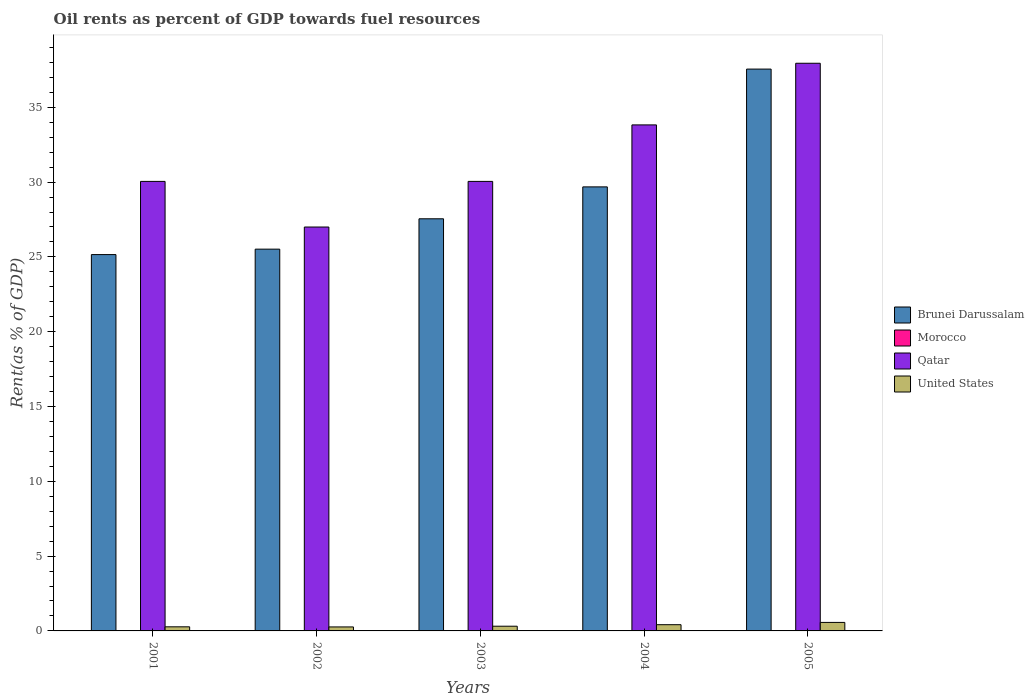How many different coloured bars are there?
Make the answer very short. 4. How many groups of bars are there?
Offer a terse response. 5. Are the number of bars per tick equal to the number of legend labels?
Your answer should be very brief. Yes. Are the number of bars on each tick of the X-axis equal?
Your response must be concise. Yes. In how many cases, is the number of bars for a given year not equal to the number of legend labels?
Offer a very short reply. 0. What is the oil rent in Brunei Darussalam in 2005?
Your response must be concise. 37.55. Across all years, what is the maximum oil rent in Qatar?
Ensure brevity in your answer.  37.94. Across all years, what is the minimum oil rent in Morocco?
Your response must be concise. 0. In which year was the oil rent in United States minimum?
Make the answer very short. 2002. What is the total oil rent in Brunei Darussalam in the graph?
Make the answer very short. 145.45. What is the difference between the oil rent in Qatar in 2003 and that in 2004?
Give a very brief answer. -3.78. What is the difference between the oil rent in Brunei Darussalam in 2001 and the oil rent in United States in 2004?
Offer a very short reply. 24.74. What is the average oil rent in Morocco per year?
Provide a succinct answer. 0. In the year 2005, what is the difference between the oil rent in United States and oil rent in Brunei Darussalam?
Ensure brevity in your answer.  -36.98. What is the ratio of the oil rent in Qatar in 2002 to that in 2003?
Keep it short and to the point. 0.9. Is the oil rent in Morocco in 2001 less than that in 2004?
Provide a succinct answer. Yes. What is the difference between the highest and the second highest oil rent in Brunei Darussalam?
Make the answer very short. 7.87. What is the difference between the highest and the lowest oil rent in Qatar?
Your answer should be very brief. 10.95. In how many years, is the oil rent in United States greater than the average oil rent in United States taken over all years?
Offer a terse response. 2. What does the 4th bar from the left in 2005 represents?
Your answer should be compact. United States. What does the 3rd bar from the right in 2002 represents?
Make the answer very short. Morocco. Is it the case that in every year, the sum of the oil rent in Morocco and oil rent in Qatar is greater than the oil rent in Brunei Darussalam?
Give a very brief answer. Yes. How many bars are there?
Your answer should be compact. 20. How many years are there in the graph?
Make the answer very short. 5. What is the difference between two consecutive major ticks on the Y-axis?
Offer a terse response. 5. Are the values on the major ticks of Y-axis written in scientific E-notation?
Ensure brevity in your answer.  No. Does the graph contain any zero values?
Provide a short and direct response. No. Does the graph contain grids?
Provide a succinct answer. No. How many legend labels are there?
Provide a succinct answer. 4. What is the title of the graph?
Keep it short and to the point. Oil rents as percent of GDP towards fuel resources. What is the label or title of the X-axis?
Your answer should be compact. Years. What is the label or title of the Y-axis?
Provide a short and direct response. Rent(as % of GDP). What is the Rent(as % of GDP) in Brunei Darussalam in 2001?
Make the answer very short. 25.15. What is the Rent(as % of GDP) of Morocco in 2001?
Your answer should be compact. 0. What is the Rent(as % of GDP) of Qatar in 2001?
Ensure brevity in your answer.  30.05. What is the Rent(as % of GDP) in United States in 2001?
Your answer should be compact. 0.27. What is the Rent(as % of GDP) in Brunei Darussalam in 2002?
Make the answer very short. 25.52. What is the Rent(as % of GDP) in Morocco in 2002?
Your answer should be compact. 0. What is the Rent(as % of GDP) in Qatar in 2002?
Offer a very short reply. 27. What is the Rent(as % of GDP) of United States in 2002?
Provide a short and direct response. 0.27. What is the Rent(as % of GDP) in Brunei Darussalam in 2003?
Offer a very short reply. 27.55. What is the Rent(as % of GDP) in Morocco in 2003?
Give a very brief answer. 0. What is the Rent(as % of GDP) of Qatar in 2003?
Offer a terse response. 30.05. What is the Rent(as % of GDP) of United States in 2003?
Your response must be concise. 0.31. What is the Rent(as % of GDP) in Brunei Darussalam in 2004?
Provide a short and direct response. 29.68. What is the Rent(as % of GDP) of Morocco in 2004?
Your response must be concise. 0. What is the Rent(as % of GDP) of Qatar in 2004?
Give a very brief answer. 33.82. What is the Rent(as % of GDP) of United States in 2004?
Offer a very short reply. 0.42. What is the Rent(as % of GDP) of Brunei Darussalam in 2005?
Provide a short and direct response. 37.55. What is the Rent(as % of GDP) of Morocco in 2005?
Make the answer very short. 0. What is the Rent(as % of GDP) of Qatar in 2005?
Offer a terse response. 37.94. What is the Rent(as % of GDP) of United States in 2005?
Provide a short and direct response. 0.57. Across all years, what is the maximum Rent(as % of GDP) of Brunei Darussalam?
Provide a succinct answer. 37.55. Across all years, what is the maximum Rent(as % of GDP) of Morocco?
Provide a succinct answer. 0. Across all years, what is the maximum Rent(as % of GDP) in Qatar?
Give a very brief answer. 37.94. Across all years, what is the maximum Rent(as % of GDP) in United States?
Keep it short and to the point. 0.57. Across all years, what is the minimum Rent(as % of GDP) of Brunei Darussalam?
Offer a very short reply. 25.15. Across all years, what is the minimum Rent(as % of GDP) of Morocco?
Your answer should be very brief. 0. Across all years, what is the minimum Rent(as % of GDP) of Qatar?
Your answer should be compact. 27. Across all years, what is the minimum Rent(as % of GDP) of United States?
Offer a very short reply. 0.27. What is the total Rent(as % of GDP) in Brunei Darussalam in the graph?
Your response must be concise. 145.45. What is the total Rent(as % of GDP) of Morocco in the graph?
Offer a terse response. 0.02. What is the total Rent(as % of GDP) of Qatar in the graph?
Make the answer very short. 158.85. What is the total Rent(as % of GDP) in United States in the graph?
Offer a terse response. 1.84. What is the difference between the Rent(as % of GDP) of Brunei Darussalam in 2001 and that in 2002?
Provide a succinct answer. -0.36. What is the difference between the Rent(as % of GDP) in Morocco in 2001 and that in 2002?
Your answer should be very brief. -0. What is the difference between the Rent(as % of GDP) of Qatar in 2001 and that in 2002?
Keep it short and to the point. 3.05. What is the difference between the Rent(as % of GDP) of United States in 2001 and that in 2002?
Offer a terse response. 0.01. What is the difference between the Rent(as % of GDP) of Brunei Darussalam in 2001 and that in 2003?
Keep it short and to the point. -2.39. What is the difference between the Rent(as % of GDP) of United States in 2001 and that in 2003?
Offer a very short reply. -0.04. What is the difference between the Rent(as % of GDP) of Brunei Darussalam in 2001 and that in 2004?
Your answer should be compact. -4.53. What is the difference between the Rent(as % of GDP) of Morocco in 2001 and that in 2004?
Make the answer very short. -0. What is the difference between the Rent(as % of GDP) of Qatar in 2001 and that in 2004?
Your answer should be compact. -3.78. What is the difference between the Rent(as % of GDP) of United States in 2001 and that in 2004?
Your response must be concise. -0.14. What is the difference between the Rent(as % of GDP) of Brunei Darussalam in 2001 and that in 2005?
Give a very brief answer. -12.4. What is the difference between the Rent(as % of GDP) of Morocco in 2001 and that in 2005?
Offer a very short reply. -0. What is the difference between the Rent(as % of GDP) of Qatar in 2001 and that in 2005?
Offer a very short reply. -7.9. What is the difference between the Rent(as % of GDP) of United States in 2001 and that in 2005?
Give a very brief answer. -0.29. What is the difference between the Rent(as % of GDP) of Brunei Darussalam in 2002 and that in 2003?
Your answer should be very brief. -2.03. What is the difference between the Rent(as % of GDP) in Morocco in 2002 and that in 2003?
Provide a short and direct response. 0. What is the difference between the Rent(as % of GDP) in Qatar in 2002 and that in 2003?
Ensure brevity in your answer.  -3.05. What is the difference between the Rent(as % of GDP) of United States in 2002 and that in 2003?
Provide a short and direct response. -0.05. What is the difference between the Rent(as % of GDP) of Brunei Darussalam in 2002 and that in 2004?
Give a very brief answer. -4.16. What is the difference between the Rent(as % of GDP) of Qatar in 2002 and that in 2004?
Your response must be concise. -6.83. What is the difference between the Rent(as % of GDP) of United States in 2002 and that in 2004?
Your answer should be compact. -0.15. What is the difference between the Rent(as % of GDP) in Brunei Darussalam in 2002 and that in 2005?
Make the answer very short. -12.04. What is the difference between the Rent(as % of GDP) in Morocco in 2002 and that in 2005?
Provide a succinct answer. 0. What is the difference between the Rent(as % of GDP) of Qatar in 2002 and that in 2005?
Your response must be concise. -10.95. What is the difference between the Rent(as % of GDP) in United States in 2002 and that in 2005?
Offer a terse response. -0.3. What is the difference between the Rent(as % of GDP) in Brunei Darussalam in 2003 and that in 2004?
Your answer should be compact. -2.13. What is the difference between the Rent(as % of GDP) in Morocco in 2003 and that in 2004?
Offer a very short reply. -0. What is the difference between the Rent(as % of GDP) in Qatar in 2003 and that in 2004?
Offer a terse response. -3.78. What is the difference between the Rent(as % of GDP) of United States in 2003 and that in 2004?
Make the answer very short. -0.1. What is the difference between the Rent(as % of GDP) of Brunei Darussalam in 2003 and that in 2005?
Your answer should be compact. -10.01. What is the difference between the Rent(as % of GDP) in Morocco in 2003 and that in 2005?
Provide a short and direct response. -0. What is the difference between the Rent(as % of GDP) in Qatar in 2003 and that in 2005?
Make the answer very short. -7.9. What is the difference between the Rent(as % of GDP) in United States in 2003 and that in 2005?
Keep it short and to the point. -0.25. What is the difference between the Rent(as % of GDP) in Brunei Darussalam in 2004 and that in 2005?
Your answer should be very brief. -7.87. What is the difference between the Rent(as % of GDP) in Morocco in 2004 and that in 2005?
Your answer should be compact. 0. What is the difference between the Rent(as % of GDP) in Qatar in 2004 and that in 2005?
Keep it short and to the point. -4.12. What is the difference between the Rent(as % of GDP) of United States in 2004 and that in 2005?
Your response must be concise. -0.15. What is the difference between the Rent(as % of GDP) of Brunei Darussalam in 2001 and the Rent(as % of GDP) of Morocco in 2002?
Offer a terse response. 25.15. What is the difference between the Rent(as % of GDP) of Brunei Darussalam in 2001 and the Rent(as % of GDP) of Qatar in 2002?
Make the answer very short. -1.84. What is the difference between the Rent(as % of GDP) in Brunei Darussalam in 2001 and the Rent(as % of GDP) in United States in 2002?
Offer a terse response. 24.89. What is the difference between the Rent(as % of GDP) of Morocco in 2001 and the Rent(as % of GDP) of Qatar in 2002?
Your answer should be compact. -26.99. What is the difference between the Rent(as % of GDP) of Morocco in 2001 and the Rent(as % of GDP) of United States in 2002?
Your response must be concise. -0.26. What is the difference between the Rent(as % of GDP) in Qatar in 2001 and the Rent(as % of GDP) in United States in 2002?
Your answer should be very brief. 29.78. What is the difference between the Rent(as % of GDP) in Brunei Darussalam in 2001 and the Rent(as % of GDP) in Morocco in 2003?
Your answer should be very brief. 25.15. What is the difference between the Rent(as % of GDP) in Brunei Darussalam in 2001 and the Rent(as % of GDP) in Qatar in 2003?
Your answer should be very brief. -4.89. What is the difference between the Rent(as % of GDP) of Brunei Darussalam in 2001 and the Rent(as % of GDP) of United States in 2003?
Offer a very short reply. 24.84. What is the difference between the Rent(as % of GDP) of Morocco in 2001 and the Rent(as % of GDP) of Qatar in 2003?
Provide a succinct answer. -30.04. What is the difference between the Rent(as % of GDP) in Morocco in 2001 and the Rent(as % of GDP) in United States in 2003?
Ensure brevity in your answer.  -0.31. What is the difference between the Rent(as % of GDP) in Qatar in 2001 and the Rent(as % of GDP) in United States in 2003?
Offer a very short reply. 29.73. What is the difference between the Rent(as % of GDP) in Brunei Darussalam in 2001 and the Rent(as % of GDP) in Morocco in 2004?
Keep it short and to the point. 25.15. What is the difference between the Rent(as % of GDP) in Brunei Darussalam in 2001 and the Rent(as % of GDP) in Qatar in 2004?
Provide a succinct answer. -8.67. What is the difference between the Rent(as % of GDP) of Brunei Darussalam in 2001 and the Rent(as % of GDP) of United States in 2004?
Your answer should be compact. 24.74. What is the difference between the Rent(as % of GDP) of Morocco in 2001 and the Rent(as % of GDP) of Qatar in 2004?
Keep it short and to the point. -33.82. What is the difference between the Rent(as % of GDP) of Morocco in 2001 and the Rent(as % of GDP) of United States in 2004?
Offer a very short reply. -0.41. What is the difference between the Rent(as % of GDP) of Qatar in 2001 and the Rent(as % of GDP) of United States in 2004?
Ensure brevity in your answer.  29.63. What is the difference between the Rent(as % of GDP) of Brunei Darussalam in 2001 and the Rent(as % of GDP) of Morocco in 2005?
Your response must be concise. 25.15. What is the difference between the Rent(as % of GDP) in Brunei Darussalam in 2001 and the Rent(as % of GDP) in Qatar in 2005?
Provide a short and direct response. -12.79. What is the difference between the Rent(as % of GDP) of Brunei Darussalam in 2001 and the Rent(as % of GDP) of United States in 2005?
Make the answer very short. 24.59. What is the difference between the Rent(as % of GDP) in Morocco in 2001 and the Rent(as % of GDP) in Qatar in 2005?
Provide a succinct answer. -37.94. What is the difference between the Rent(as % of GDP) in Morocco in 2001 and the Rent(as % of GDP) in United States in 2005?
Ensure brevity in your answer.  -0.56. What is the difference between the Rent(as % of GDP) in Qatar in 2001 and the Rent(as % of GDP) in United States in 2005?
Your response must be concise. 29.48. What is the difference between the Rent(as % of GDP) of Brunei Darussalam in 2002 and the Rent(as % of GDP) of Morocco in 2003?
Your answer should be very brief. 25.51. What is the difference between the Rent(as % of GDP) in Brunei Darussalam in 2002 and the Rent(as % of GDP) in Qatar in 2003?
Ensure brevity in your answer.  -4.53. What is the difference between the Rent(as % of GDP) of Brunei Darussalam in 2002 and the Rent(as % of GDP) of United States in 2003?
Give a very brief answer. 25.2. What is the difference between the Rent(as % of GDP) of Morocco in 2002 and the Rent(as % of GDP) of Qatar in 2003?
Provide a succinct answer. -30.04. What is the difference between the Rent(as % of GDP) in Morocco in 2002 and the Rent(as % of GDP) in United States in 2003?
Provide a short and direct response. -0.31. What is the difference between the Rent(as % of GDP) in Qatar in 2002 and the Rent(as % of GDP) in United States in 2003?
Provide a succinct answer. 26.68. What is the difference between the Rent(as % of GDP) in Brunei Darussalam in 2002 and the Rent(as % of GDP) in Morocco in 2004?
Your answer should be very brief. 25.51. What is the difference between the Rent(as % of GDP) in Brunei Darussalam in 2002 and the Rent(as % of GDP) in Qatar in 2004?
Ensure brevity in your answer.  -8.3. What is the difference between the Rent(as % of GDP) of Brunei Darussalam in 2002 and the Rent(as % of GDP) of United States in 2004?
Make the answer very short. 25.1. What is the difference between the Rent(as % of GDP) of Morocco in 2002 and the Rent(as % of GDP) of Qatar in 2004?
Your answer should be compact. -33.82. What is the difference between the Rent(as % of GDP) in Morocco in 2002 and the Rent(as % of GDP) in United States in 2004?
Offer a terse response. -0.41. What is the difference between the Rent(as % of GDP) in Qatar in 2002 and the Rent(as % of GDP) in United States in 2004?
Ensure brevity in your answer.  26.58. What is the difference between the Rent(as % of GDP) in Brunei Darussalam in 2002 and the Rent(as % of GDP) in Morocco in 2005?
Offer a terse response. 25.51. What is the difference between the Rent(as % of GDP) of Brunei Darussalam in 2002 and the Rent(as % of GDP) of Qatar in 2005?
Provide a succinct answer. -12.43. What is the difference between the Rent(as % of GDP) in Brunei Darussalam in 2002 and the Rent(as % of GDP) in United States in 2005?
Provide a short and direct response. 24.95. What is the difference between the Rent(as % of GDP) in Morocco in 2002 and the Rent(as % of GDP) in Qatar in 2005?
Your response must be concise. -37.94. What is the difference between the Rent(as % of GDP) of Morocco in 2002 and the Rent(as % of GDP) of United States in 2005?
Keep it short and to the point. -0.56. What is the difference between the Rent(as % of GDP) of Qatar in 2002 and the Rent(as % of GDP) of United States in 2005?
Provide a short and direct response. 26.43. What is the difference between the Rent(as % of GDP) of Brunei Darussalam in 2003 and the Rent(as % of GDP) of Morocco in 2004?
Offer a terse response. 27.54. What is the difference between the Rent(as % of GDP) in Brunei Darussalam in 2003 and the Rent(as % of GDP) in Qatar in 2004?
Ensure brevity in your answer.  -6.28. What is the difference between the Rent(as % of GDP) of Brunei Darussalam in 2003 and the Rent(as % of GDP) of United States in 2004?
Keep it short and to the point. 27.13. What is the difference between the Rent(as % of GDP) in Morocco in 2003 and the Rent(as % of GDP) in Qatar in 2004?
Offer a very short reply. -33.82. What is the difference between the Rent(as % of GDP) in Morocco in 2003 and the Rent(as % of GDP) in United States in 2004?
Ensure brevity in your answer.  -0.41. What is the difference between the Rent(as % of GDP) in Qatar in 2003 and the Rent(as % of GDP) in United States in 2004?
Give a very brief answer. 29.63. What is the difference between the Rent(as % of GDP) in Brunei Darussalam in 2003 and the Rent(as % of GDP) in Morocco in 2005?
Ensure brevity in your answer.  27.54. What is the difference between the Rent(as % of GDP) of Brunei Darussalam in 2003 and the Rent(as % of GDP) of Qatar in 2005?
Your answer should be compact. -10.4. What is the difference between the Rent(as % of GDP) of Brunei Darussalam in 2003 and the Rent(as % of GDP) of United States in 2005?
Your answer should be compact. 26.98. What is the difference between the Rent(as % of GDP) of Morocco in 2003 and the Rent(as % of GDP) of Qatar in 2005?
Keep it short and to the point. -37.94. What is the difference between the Rent(as % of GDP) in Morocco in 2003 and the Rent(as % of GDP) in United States in 2005?
Give a very brief answer. -0.57. What is the difference between the Rent(as % of GDP) of Qatar in 2003 and the Rent(as % of GDP) of United States in 2005?
Give a very brief answer. 29.48. What is the difference between the Rent(as % of GDP) of Brunei Darussalam in 2004 and the Rent(as % of GDP) of Morocco in 2005?
Provide a short and direct response. 29.68. What is the difference between the Rent(as % of GDP) of Brunei Darussalam in 2004 and the Rent(as % of GDP) of Qatar in 2005?
Give a very brief answer. -8.26. What is the difference between the Rent(as % of GDP) of Brunei Darussalam in 2004 and the Rent(as % of GDP) of United States in 2005?
Provide a short and direct response. 29.11. What is the difference between the Rent(as % of GDP) in Morocco in 2004 and the Rent(as % of GDP) in Qatar in 2005?
Your response must be concise. -37.94. What is the difference between the Rent(as % of GDP) in Morocco in 2004 and the Rent(as % of GDP) in United States in 2005?
Keep it short and to the point. -0.56. What is the difference between the Rent(as % of GDP) in Qatar in 2004 and the Rent(as % of GDP) in United States in 2005?
Keep it short and to the point. 33.25. What is the average Rent(as % of GDP) of Brunei Darussalam per year?
Make the answer very short. 29.09. What is the average Rent(as % of GDP) in Morocco per year?
Make the answer very short. 0. What is the average Rent(as % of GDP) of Qatar per year?
Provide a succinct answer. 31.77. What is the average Rent(as % of GDP) in United States per year?
Your response must be concise. 0.37. In the year 2001, what is the difference between the Rent(as % of GDP) of Brunei Darussalam and Rent(as % of GDP) of Morocco?
Offer a very short reply. 25.15. In the year 2001, what is the difference between the Rent(as % of GDP) of Brunei Darussalam and Rent(as % of GDP) of Qatar?
Your response must be concise. -4.89. In the year 2001, what is the difference between the Rent(as % of GDP) of Brunei Darussalam and Rent(as % of GDP) of United States?
Provide a short and direct response. 24.88. In the year 2001, what is the difference between the Rent(as % of GDP) in Morocco and Rent(as % of GDP) in Qatar?
Keep it short and to the point. -30.04. In the year 2001, what is the difference between the Rent(as % of GDP) in Morocco and Rent(as % of GDP) in United States?
Keep it short and to the point. -0.27. In the year 2001, what is the difference between the Rent(as % of GDP) of Qatar and Rent(as % of GDP) of United States?
Offer a very short reply. 29.77. In the year 2002, what is the difference between the Rent(as % of GDP) of Brunei Darussalam and Rent(as % of GDP) of Morocco?
Provide a short and direct response. 25.51. In the year 2002, what is the difference between the Rent(as % of GDP) in Brunei Darussalam and Rent(as % of GDP) in Qatar?
Your answer should be compact. -1.48. In the year 2002, what is the difference between the Rent(as % of GDP) of Brunei Darussalam and Rent(as % of GDP) of United States?
Ensure brevity in your answer.  25.25. In the year 2002, what is the difference between the Rent(as % of GDP) in Morocco and Rent(as % of GDP) in Qatar?
Offer a terse response. -26.99. In the year 2002, what is the difference between the Rent(as % of GDP) of Morocco and Rent(as % of GDP) of United States?
Provide a short and direct response. -0.26. In the year 2002, what is the difference between the Rent(as % of GDP) of Qatar and Rent(as % of GDP) of United States?
Your answer should be compact. 26.73. In the year 2003, what is the difference between the Rent(as % of GDP) of Brunei Darussalam and Rent(as % of GDP) of Morocco?
Provide a short and direct response. 27.54. In the year 2003, what is the difference between the Rent(as % of GDP) of Brunei Darussalam and Rent(as % of GDP) of Qatar?
Give a very brief answer. -2.5. In the year 2003, what is the difference between the Rent(as % of GDP) of Brunei Darussalam and Rent(as % of GDP) of United States?
Offer a very short reply. 27.23. In the year 2003, what is the difference between the Rent(as % of GDP) of Morocco and Rent(as % of GDP) of Qatar?
Your answer should be very brief. -30.04. In the year 2003, what is the difference between the Rent(as % of GDP) of Morocco and Rent(as % of GDP) of United States?
Offer a very short reply. -0.31. In the year 2003, what is the difference between the Rent(as % of GDP) in Qatar and Rent(as % of GDP) in United States?
Your response must be concise. 29.73. In the year 2004, what is the difference between the Rent(as % of GDP) of Brunei Darussalam and Rent(as % of GDP) of Morocco?
Your answer should be very brief. 29.67. In the year 2004, what is the difference between the Rent(as % of GDP) of Brunei Darussalam and Rent(as % of GDP) of Qatar?
Your answer should be very brief. -4.14. In the year 2004, what is the difference between the Rent(as % of GDP) of Brunei Darussalam and Rent(as % of GDP) of United States?
Provide a succinct answer. 29.26. In the year 2004, what is the difference between the Rent(as % of GDP) in Morocco and Rent(as % of GDP) in Qatar?
Give a very brief answer. -33.82. In the year 2004, what is the difference between the Rent(as % of GDP) in Morocco and Rent(as % of GDP) in United States?
Give a very brief answer. -0.41. In the year 2004, what is the difference between the Rent(as % of GDP) of Qatar and Rent(as % of GDP) of United States?
Provide a short and direct response. 33.41. In the year 2005, what is the difference between the Rent(as % of GDP) in Brunei Darussalam and Rent(as % of GDP) in Morocco?
Your answer should be very brief. 37.55. In the year 2005, what is the difference between the Rent(as % of GDP) in Brunei Darussalam and Rent(as % of GDP) in Qatar?
Give a very brief answer. -0.39. In the year 2005, what is the difference between the Rent(as % of GDP) of Brunei Darussalam and Rent(as % of GDP) of United States?
Your answer should be very brief. 36.98. In the year 2005, what is the difference between the Rent(as % of GDP) in Morocco and Rent(as % of GDP) in Qatar?
Your answer should be compact. -37.94. In the year 2005, what is the difference between the Rent(as % of GDP) in Morocco and Rent(as % of GDP) in United States?
Keep it short and to the point. -0.56. In the year 2005, what is the difference between the Rent(as % of GDP) in Qatar and Rent(as % of GDP) in United States?
Offer a very short reply. 37.37. What is the ratio of the Rent(as % of GDP) of Brunei Darussalam in 2001 to that in 2002?
Give a very brief answer. 0.99. What is the ratio of the Rent(as % of GDP) of Morocco in 2001 to that in 2002?
Offer a terse response. 0.81. What is the ratio of the Rent(as % of GDP) in Qatar in 2001 to that in 2002?
Ensure brevity in your answer.  1.11. What is the ratio of the Rent(as % of GDP) in United States in 2001 to that in 2002?
Your response must be concise. 1.03. What is the ratio of the Rent(as % of GDP) of Brunei Darussalam in 2001 to that in 2003?
Give a very brief answer. 0.91. What is the ratio of the Rent(as % of GDP) of Morocco in 2001 to that in 2003?
Offer a very short reply. 1.09. What is the ratio of the Rent(as % of GDP) in Qatar in 2001 to that in 2003?
Offer a terse response. 1. What is the ratio of the Rent(as % of GDP) of United States in 2001 to that in 2003?
Your answer should be compact. 0.87. What is the ratio of the Rent(as % of GDP) of Brunei Darussalam in 2001 to that in 2004?
Offer a terse response. 0.85. What is the ratio of the Rent(as % of GDP) of Morocco in 2001 to that in 2004?
Provide a short and direct response. 0.84. What is the ratio of the Rent(as % of GDP) of Qatar in 2001 to that in 2004?
Give a very brief answer. 0.89. What is the ratio of the Rent(as % of GDP) of United States in 2001 to that in 2004?
Ensure brevity in your answer.  0.66. What is the ratio of the Rent(as % of GDP) of Brunei Darussalam in 2001 to that in 2005?
Provide a short and direct response. 0.67. What is the ratio of the Rent(as % of GDP) of Morocco in 2001 to that in 2005?
Your answer should be compact. 0.94. What is the ratio of the Rent(as % of GDP) in Qatar in 2001 to that in 2005?
Offer a very short reply. 0.79. What is the ratio of the Rent(as % of GDP) in United States in 2001 to that in 2005?
Offer a terse response. 0.48. What is the ratio of the Rent(as % of GDP) in Brunei Darussalam in 2002 to that in 2003?
Offer a terse response. 0.93. What is the ratio of the Rent(as % of GDP) of Morocco in 2002 to that in 2003?
Provide a short and direct response. 1.35. What is the ratio of the Rent(as % of GDP) of Qatar in 2002 to that in 2003?
Make the answer very short. 0.9. What is the ratio of the Rent(as % of GDP) of United States in 2002 to that in 2003?
Your answer should be compact. 0.85. What is the ratio of the Rent(as % of GDP) of Brunei Darussalam in 2002 to that in 2004?
Your response must be concise. 0.86. What is the ratio of the Rent(as % of GDP) in Morocco in 2002 to that in 2004?
Offer a very short reply. 1.04. What is the ratio of the Rent(as % of GDP) in Qatar in 2002 to that in 2004?
Your answer should be very brief. 0.8. What is the ratio of the Rent(as % of GDP) in United States in 2002 to that in 2004?
Provide a short and direct response. 0.64. What is the ratio of the Rent(as % of GDP) in Brunei Darussalam in 2002 to that in 2005?
Your answer should be compact. 0.68. What is the ratio of the Rent(as % of GDP) in Morocco in 2002 to that in 2005?
Provide a succinct answer. 1.17. What is the ratio of the Rent(as % of GDP) of Qatar in 2002 to that in 2005?
Ensure brevity in your answer.  0.71. What is the ratio of the Rent(as % of GDP) in United States in 2002 to that in 2005?
Your answer should be compact. 0.47. What is the ratio of the Rent(as % of GDP) in Brunei Darussalam in 2003 to that in 2004?
Offer a very short reply. 0.93. What is the ratio of the Rent(as % of GDP) in Morocco in 2003 to that in 2004?
Your response must be concise. 0.77. What is the ratio of the Rent(as % of GDP) in Qatar in 2003 to that in 2004?
Provide a short and direct response. 0.89. What is the ratio of the Rent(as % of GDP) in United States in 2003 to that in 2004?
Make the answer very short. 0.76. What is the ratio of the Rent(as % of GDP) of Brunei Darussalam in 2003 to that in 2005?
Your answer should be very brief. 0.73. What is the ratio of the Rent(as % of GDP) in Morocco in 2003 to that in 2005?
Your answer should be very brief. 0.87. What is the ratio of the Rent(as % of GDP) in Qatar in 2003 to that in 2005?
Your response must be concise. 0.79. What is the ratio of the Rent(as % of GDP) in United States in 2003 to that in 2005?
Your answer should be compact. 0.55. What is the ratio of the Rent(as % of GDP) in Brunei Darussalam in 2004 to that in 2005?
Make the answer very short. 0.79. What is the ratio of the Rent(as % of GDP) of Morocco in 2004 to that in 2005?
Keep it short and to the point. 1.13. What is the ratio of the Rent(as % of GDP) of Qatar in 2004 to that in 2005?
Offer a terse response. 0.89. What is the ratio of the Rent(as % of GDP) in United States in 2004 to that in 2005?
Make the answer very short. 0.73. What is the difference between the highest and the second highest Rent(as % of GDP) in Brunei Darussalam?
Your answer should be very brief. 7.87. What is the difference between the highest and the second highest Rent(as % of GDP) in Morocco?
Your answer should be very brief. 0. What is the difference between the highest and the second highest Rent(as % of GDP) of Qatar?
Your answer should be compact. 4.12. What is the difference between the highest and the second highest Rent(as % of GDP) of United States?
Your answer should be compact. 0.15. What is the difference between the highest and the lowest Rent(as % of GDP) in Brunei Darussalam?
Make the answer very short. 12.4. What is the difference between the highest and the lowest Rent(as % of GDP) of Morocco?
Keep it short and to the point. 0. What is the difference between the highest and the lowest Rent(as % of GDP) of Qatar?
Your answer should be very brief. 10.95. What is the difference between the highest and the lowest Rent(as % of GDP) of United States?
Ensure brevity in your answer.  0.3. 